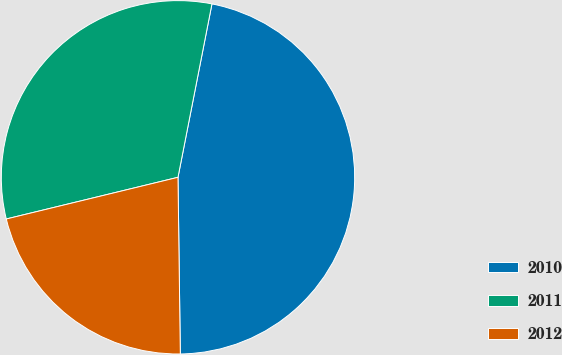<chart> <loc_0><loc_0><loc_500><loc_500><pie_chart><fcel>2010<fcel>2011<fcel>2012<nl><fcel>46.71%<fcel>31.87%<fcel>21.42%<nl></chart> 